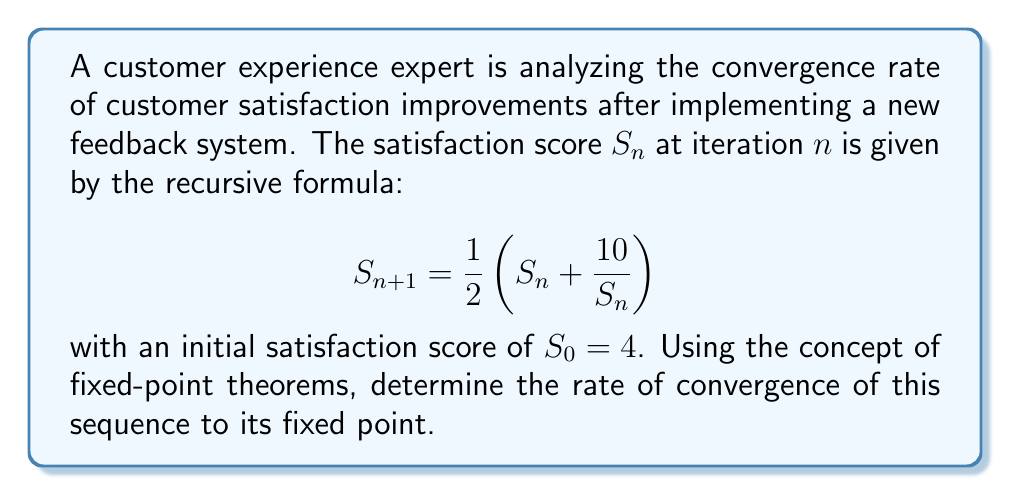Teach me how to tackle this problem. 1) First, we need to identify the fixed point of the given function. Let's call the fixed point $S^*$. At the fixed point:

   $$S^* = \frac{1}{2}(S^* + \frac{10}{S^*})$$

2) Solving this equation:
   $$2S^* = S^* + \frac{10}{S^*}$$
   $$(S^*)^2 = 10$$
   $$S^* = \sqrt{10}$$

3) Now, let's define the function:
   $$f(S) = \frac{1}{2}(S + \frac{10}{S})$$

4) To find the rate of convergence, we need to calculate $|f'(S^*)|$:
   $$f'(S) = \frac{1}{2}(1 - \frac{10}{S^2})$$

5) Evaluating at $S^* = \sqrt{10}$:
   $$|f'(S^*)| = |\frac{1}{2}(1 - \frac{10}{10})| = 0$$

6) Since $|f'(S^*)| = 0 < 1$, the sequence converges to the fixed point.

7) The rate of convergence is determined by $|f'(S^*)|$:
   - If $0 < |f'(S^*)| < 1$, the convergence is linear.
   - If $|f'(S^*)| = 0$, the convergence is quadratic.

8) In this case, $|f'(S^*)| = 0$, so the convergence is quadratic.
Answer: Quadratic convergence 